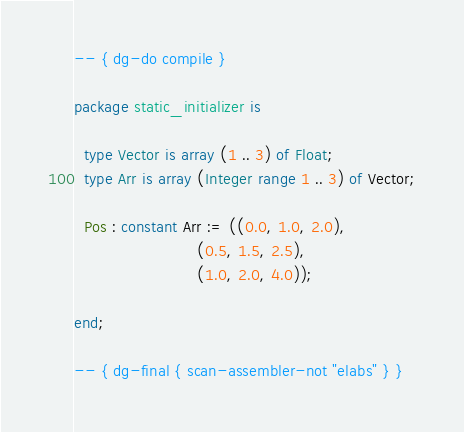<code> <loc_0><loc_0><loc_500><loc_500><_Ada_>-- { dg-do compile }

package static_initializer is

  type Vector is array (1 .. 3) of Float;
  type Arr is array (Integer range 1 .. 3) of Vector;

  Pos : constant Arr := ((0.0, 1.0, 2.0),
                         (0.5, 1.5, 2.5),
                         (1.0, 2.0, 4.0));

end;

-- { dg-final { scan-assembler-not "elabs" } }
</code> 